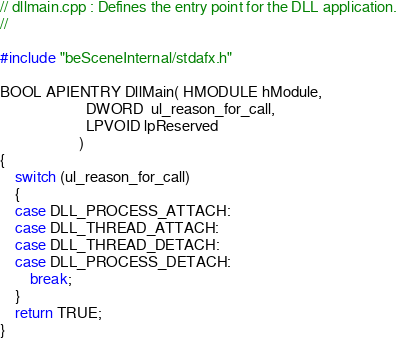Convert code to text. <code><loc_0><loc_0><loc_500><loc_500><_C++_>// dllmain.cpp : Defines the entry point for the DLL application.
//

#include "beSceneInternal/stdafx.h"

BOOL APIENTRY DllMain( HMODULE hModule,
                       DWORD  ul_reason_for_call,
                       LPVOID lpReserved
					 )
{
	switch (ul_reason_for_call)
	{
	case DLL_PROCESS_ATTACH:
	case DLL_THREAD_ATTACH:
	case DLL_THREAD_DETACH:
	case DLL_PROCESS_DETACH:
		break;
	}
	return TRUE;
}

</code> 